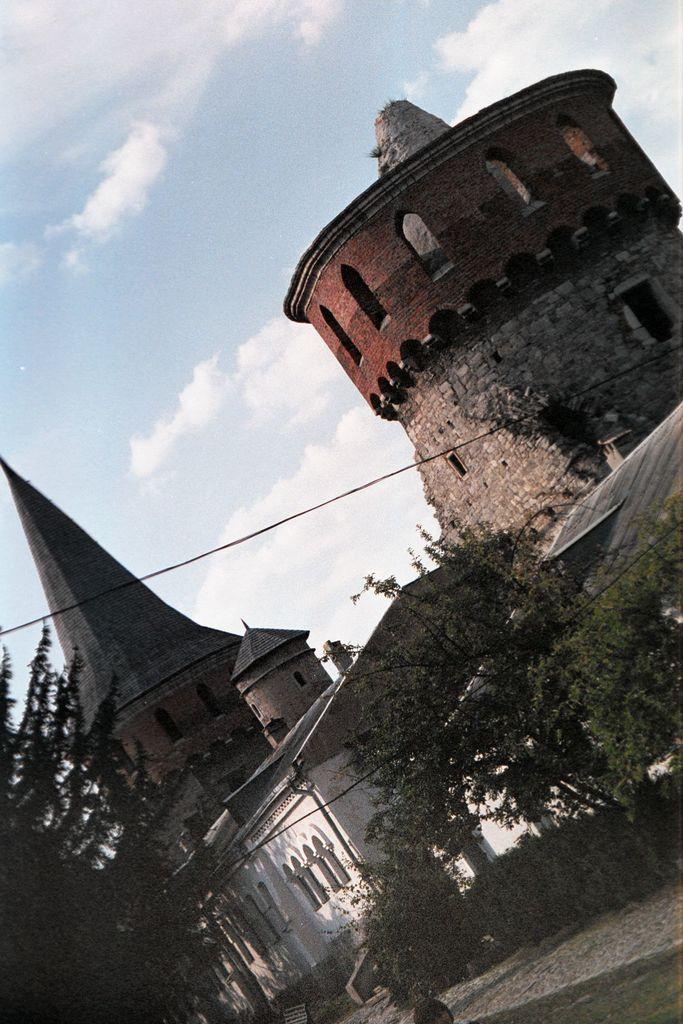What type of structures can be seen in the image? There are buildings in the image. What type of vegetation is present in the image? There are trees and grass in the image. What is visible at the top of the image? The sky is visible at the top of the image. Can you see any flames in the image? There are no flames present in the image. What type of connection can be seen between the buildings and trees in the image? There is no specific connection between the buildings and trees mentioned in the image; they are simply present in the same scene. 